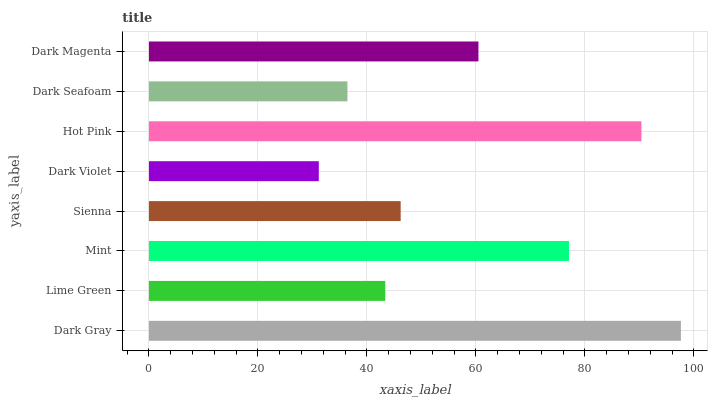Is Dark Violet the minimum?
Answer yes or no. Yes. Is Dark Gray the maximum?
Answer yes or no. Yes. Is Lime Green the minimum?
Answer yes or no. No. Is Lime Green the maximum?
Answer yes or no. No. Is Dark Gray greater than Lime Green?
Answer yes or no. Yes. Is Lime Green less than Dark Gray?
Answer yes or no. Yes. Is Lime Green greater than Dark Gray?
Answer yes or no. No. Is Dark Gray less than Lime Green?
Answer yes or no. No. Is Dark Magenta the high median?
Answer yes or no. Yes. Is Sienna the low median?
Answer yes or no. Yes. Is Hot Pink the high median?
Answer yes or no. No. Is Dark Seafoam the low median?
Answer yes or no. No. 